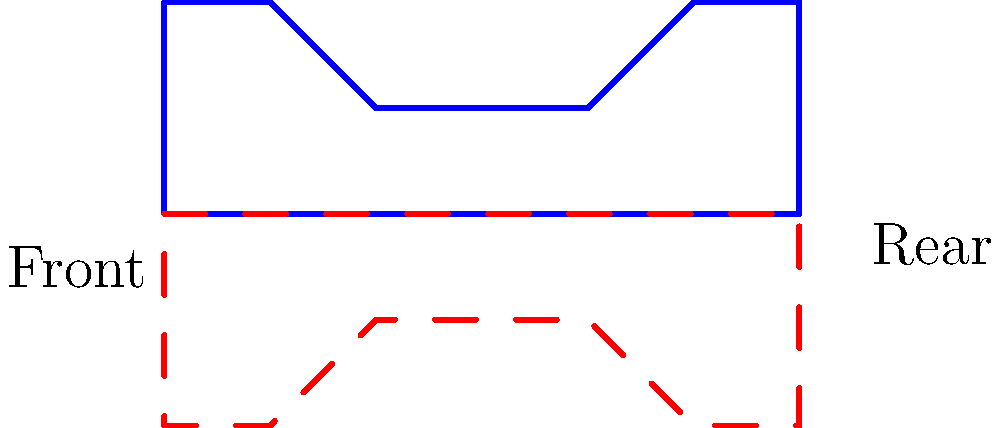In your global car culture documentation, you've noticed interesting symmetry patterns in vehicle designs. The image shows a side-view silhouette of a car (blue solid line) and its reflection (red dashed line). How many points of the original car silhouette coincide perfectly with its reflection, excluding the two points where the silhouette meets the ground? To solve this problem, we need to analyze the symmetry of the car silhouette with respect to its vertical midline. Let's break it down step-by-step:

1. The car silhouette is represented by the blue solid line, while its reflection is shown by the red dashed line.

2. The reflection is done across the vertical line that passes through the midpoint of the car's length (between "Front" and "Rear").

3. We need to identify the points where the original silhouette and its reflection overlap perfectly, excluding the ground contact points.

4. Starting from the front:
   a. The front edge of the car (point H) aligns with its reflection.
   b. The rear edge of the car (point C) also aligns with its reflection.

5. The middle section of the car (points E and F) does not align perfectly with the reflection, creating an asymmetrical profile.

6. We don't count the ground contact points (A and B) as per the question's instruction.

Therefore, we can conclude that there are 2 points (H and C) where the original car silhouette coincides perfectly with its reflection, excluding the ground contact points.

This analysis highlights the often asymmetrical nature of car designs, which can be an interesting aspect to document in various car cultures around the world.
Answer: 2 points 